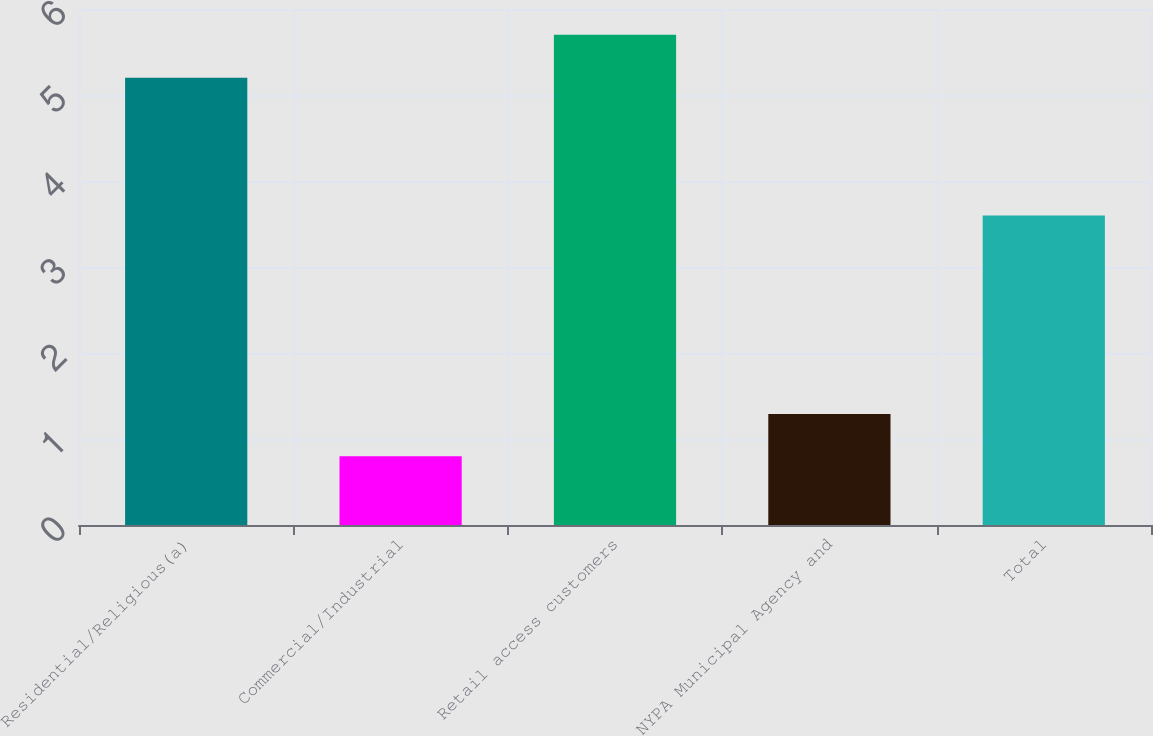<chart> <loc_0><loc_0><loc_500><loc_500><bar_chart><fcel>Residential/Religious(a)<fcel>Commercial/Industrial<fcel>Retail access customers<fcel>NYPA Municipal Agency and<fcel>Total<nl><fcel>5.2<fcel>0.8<fcel>5.7<fcel>1.29<fcel>3.6<nl></chart> 